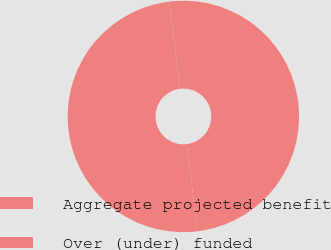<chart> <loc_0><loc_0><loc_500><loc_500><pie_chart><fcel>Aggregate projected benefit<fcel>Over (under) funded<nl><fcel>50.0%<fcel>50.0%<nl></chart> 